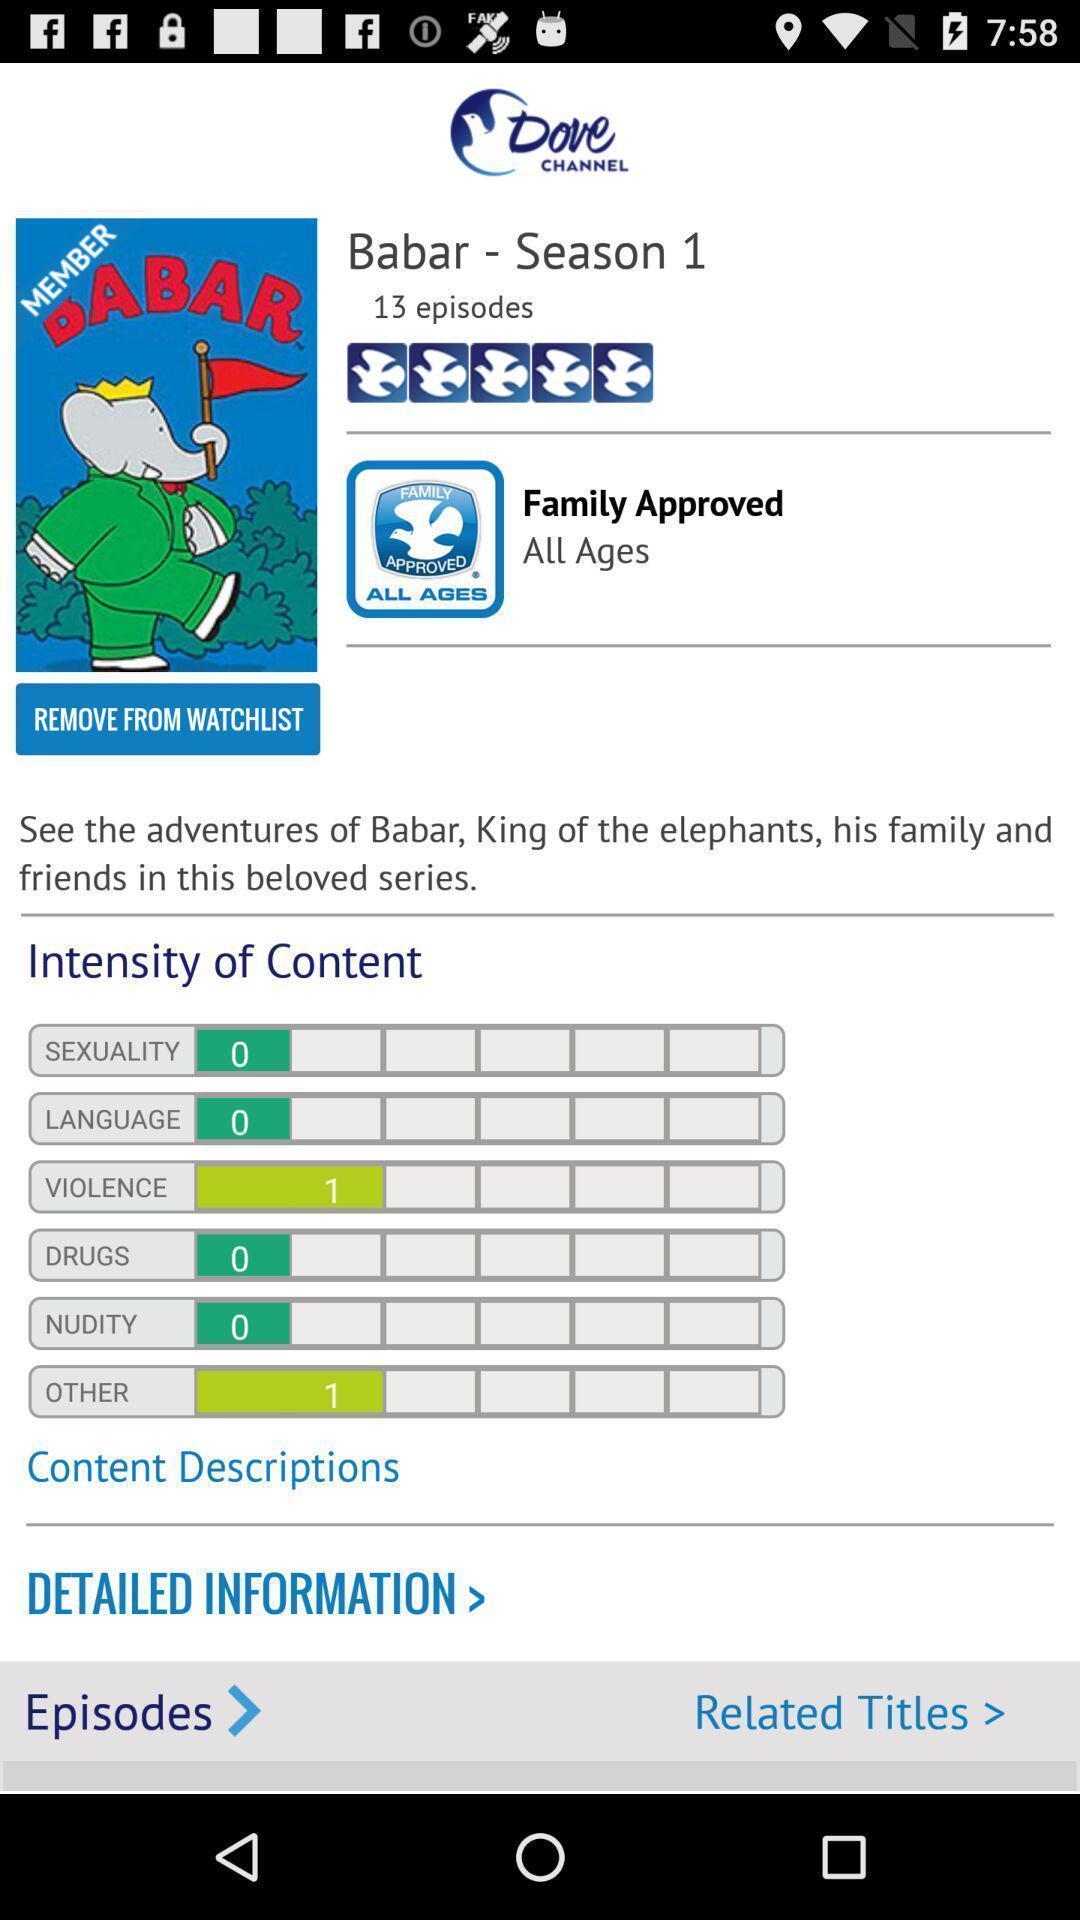Summarize the information in this screenshot. Screen page of an entertainment application. 